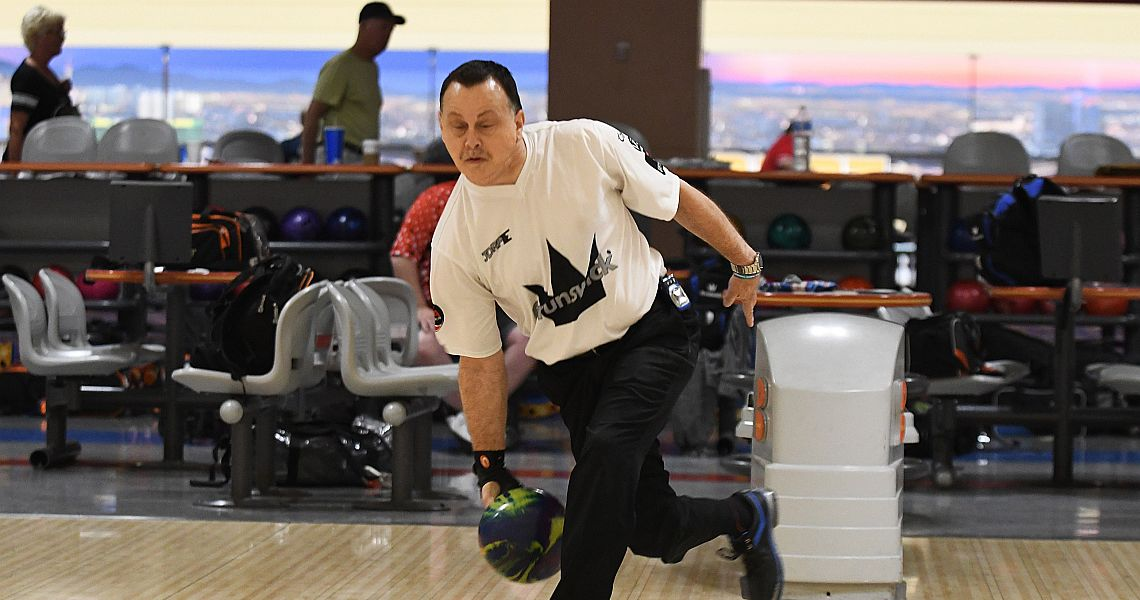Based on the attire and equipment visible in the image, what can be inferred about the level of formality and seriousness of the bowling event taking place? The attire and equipment suggest a moderately formal and serious bowling event. The man in the foreground is wearing a uniform bowling shirt with a logo, indicating that he may be part of a team or league. Personalized equipment, such as his own bowling ball, further supports this inference, as casual bowlers typically use the balls provided by the bowling alley. The organized setup and focus of the participants suggest a competitive yet friendly atmosphere, which is characteristic of a league or tournament environment where players are dedicated but also enjoy the communal aspect of the sport. 